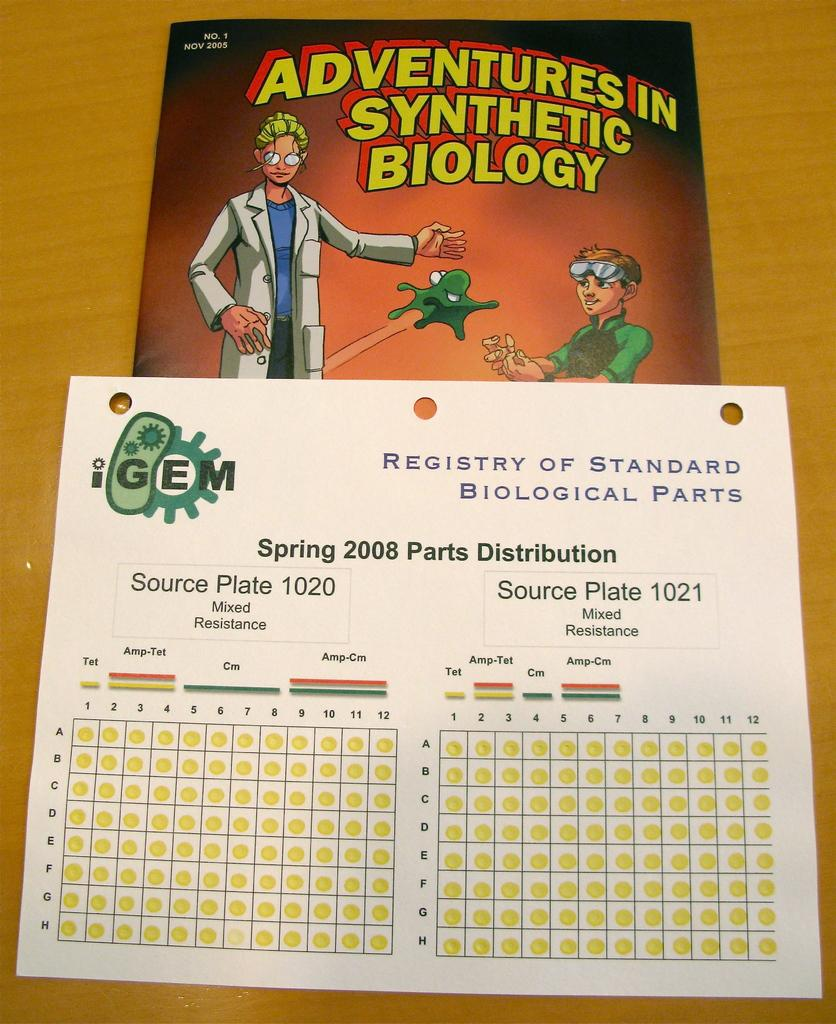<image>
Write a terse but informative summary of the picture. a spring 2008 parts distribution handout from the registry of standard biological parts 